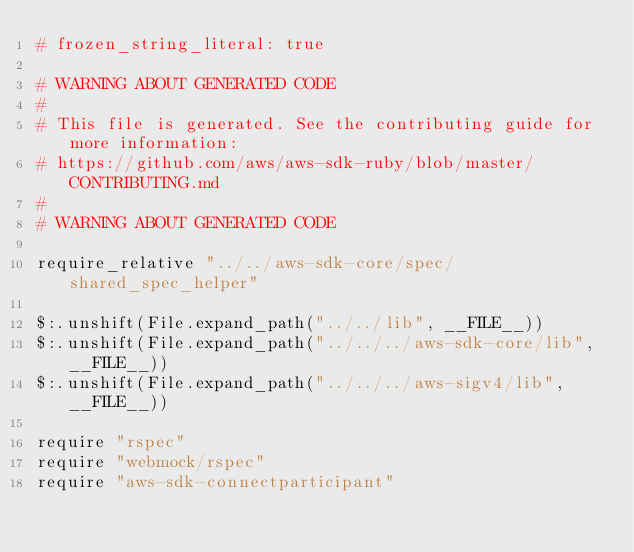<code> <loc_0><loc_0><loc_500><loc_500><_Crystal_># frozen_string_literal: true

# WARNING ABOUT GENERATED CODE
#
# This file is generated. See the contributing guide for more information:
# https://github.com/aws/aws-sdk-ruby/blob/master/CONTRIBUTING.md
#
# WARNING ABOUT GENERATED CODE

require_relative "../../aws-sdk-core/spec/shared_spec_helper"

$:.unshift(File.expand_path("../../lib", __FILE__))
$:.unshift(File.expand_path("../../../aws-sdk-core/lib", __FILE__))
$:.unshift(File.expand_path("../../../aws-sigv4/lib", __FILE__))

require "rspec"
require "webmock/rspec"
require "aws-sdk-connectparticipant"
</code> 